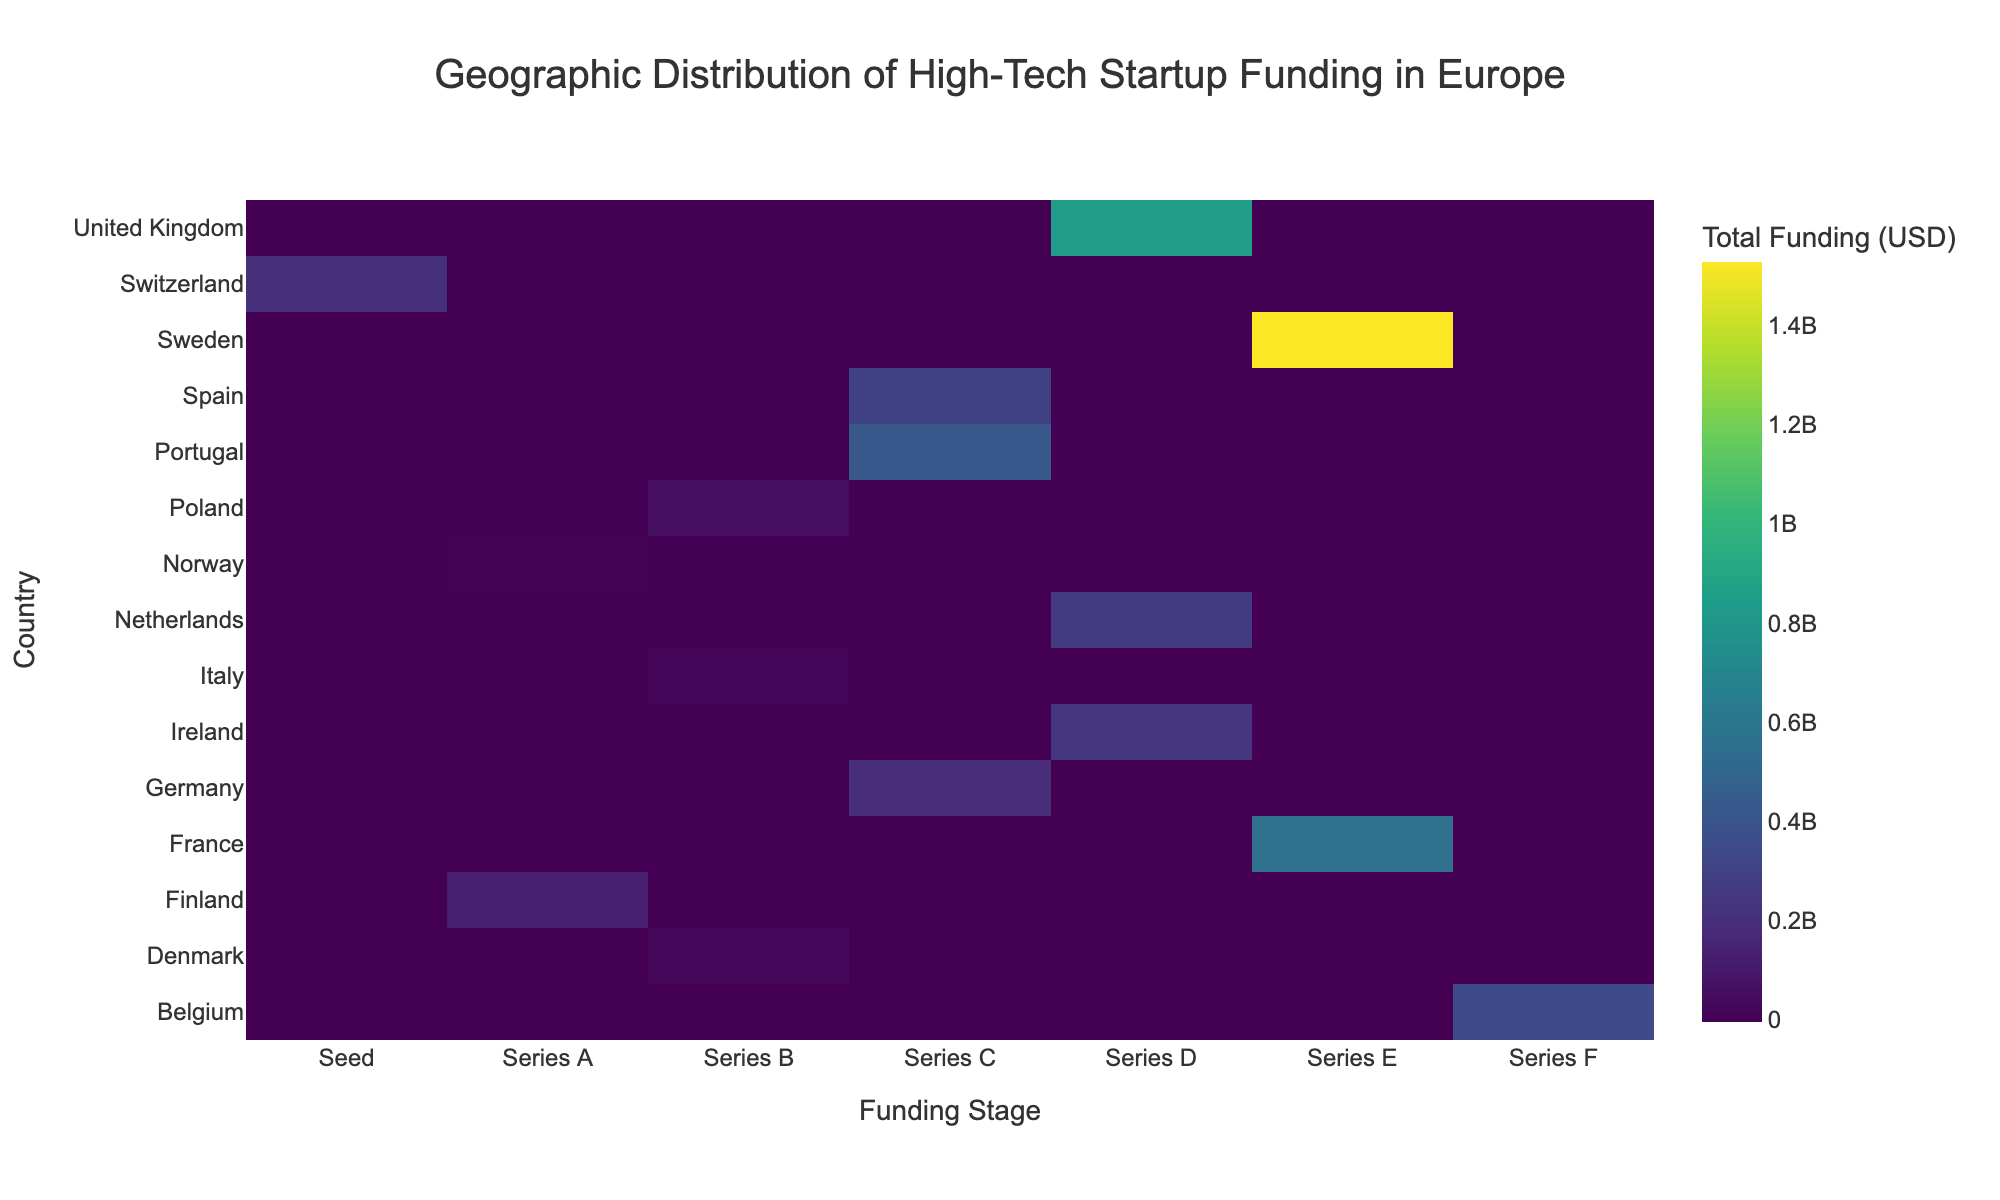Which country has the highest total funding in the 'Series E' stage? Look at the 'Series E' column and find the row with the highest value. For 'Series E', Sweden (Stockholm) with Klarna has the highest total funding amount of $1,530,000,000.
Answer: Sweden What is the title of the heatmap? The title is mentioned at the top of the heatmap. It reads "Geographic Distribution of High-Tech Startup Funding in Europe."
Answer: Geographic Distribution of High-Tech Startup Funding in Europe Which country has received funding in the 'Seed' stage? Refer to the 'Seed' column to identify the country with a non-zero value. Switzerland (Zurich) has received funding in the 'Seed' stage.
Answer: Switzerland How much total funding did the United Kingdom receive across all funding stages? Sum up the values for the United Kingdom across all the columns (Series D). Only the Series D cell for the UK has a value of $836,000,000.
Answer: $836,000,000 Which countries have startups in the 'Series B' funding stage? Look at the 'Series B' column and list countries with non-zero values. These countries are Italy (Milan), Denmark (Copenhagen), and Poland (Warsaw).
Answer: Italy, Denmark, Poland What is the total amount of funding raised in the 'Series C' stage by startups in Germany and Spain combined? Combine the values from the 'Series C' stage for Germany ($194,000,000) and Spain ($301,000,000) together. The sum is $495,000,000.
Answer: $495,000,000 Compare the total funding between France and the Netherlands in the 'Series D' stage. Which country has more funding? Look at the 'Series D' column and compare the values for France ($0) and Netherlands ($266,000,000). The Netherlands has more funding.
Answer: Netherlands Which funding stage shows the widest geographic distribution across countries? Count the number of countries with non-zero values for each funding stage (Series) column. The 'Series C' stage has the widest distribution covering four countries (Spain, Netherlands, Portugal, Germany).
Answer: Series C What color scale is used in the heatmap? Look at the colors used in the heatmap. The color scale ranges from dark purple to bright lime, known as 'Viridis'.
Answer: Viridis Which country has the least funding in any stage, and what is the amount? Look across all columns for the lowest values. Norway's (Oslo) Series A funding amounts to $7,000,000, which is the least funding in any stage.
Answer: Norway, $7,000,000 